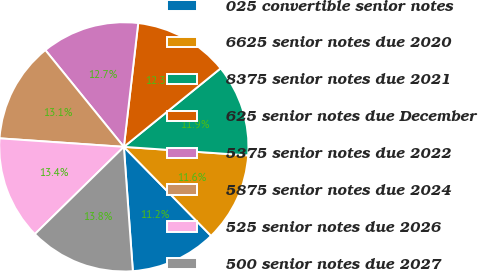<chart> <loc_0><loc_0><loc_500><loc_500><pie_chart><fcel>025 convertible senior notes<fcel>6625 senior notes due 2020<fcel>8375 senior notes due 2021<fcel>625 senior notes due December<fcel>5375 senior notes due 2022<fcel>5875 senior notes due 2024<fcel>525 senior notes due 2026<fcel>500 senior notes due 2027<nl><fcel>11.19%<fcel>11.57%<fcel>11.94%<fcel>12.31%<fcel>12.69%<fcel>13.06%<fcel>13.43%<fcel>13.81%<nl></chart> 